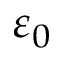Convert formula to latex. <formula><loc_0><loc_0><loc_500><loc_500>\varepsilon _ { 0 }</formula> 